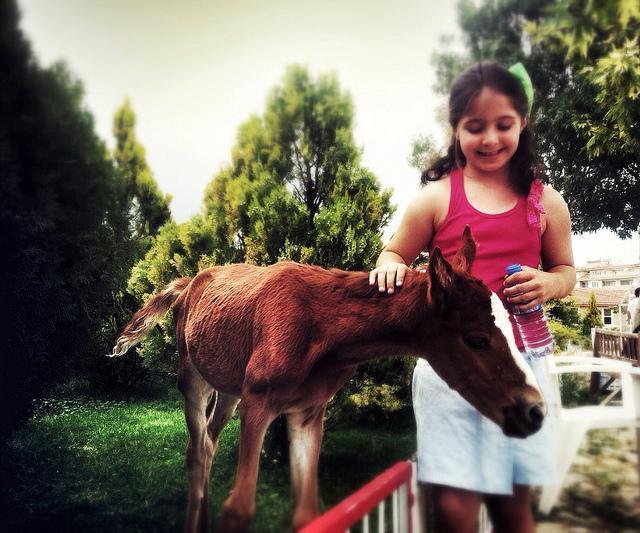What color is the cap on top of the water bottle held by the child?
Answer the question by selecting the correct answer among the 4 following choices and explain your choice with a short sentence. The answer should be formatted with the following format: `Answer: choice
Rationale: rationale.`
Options: White, black, blue, green. Answer: blue.
Rationale: The color is blue. 